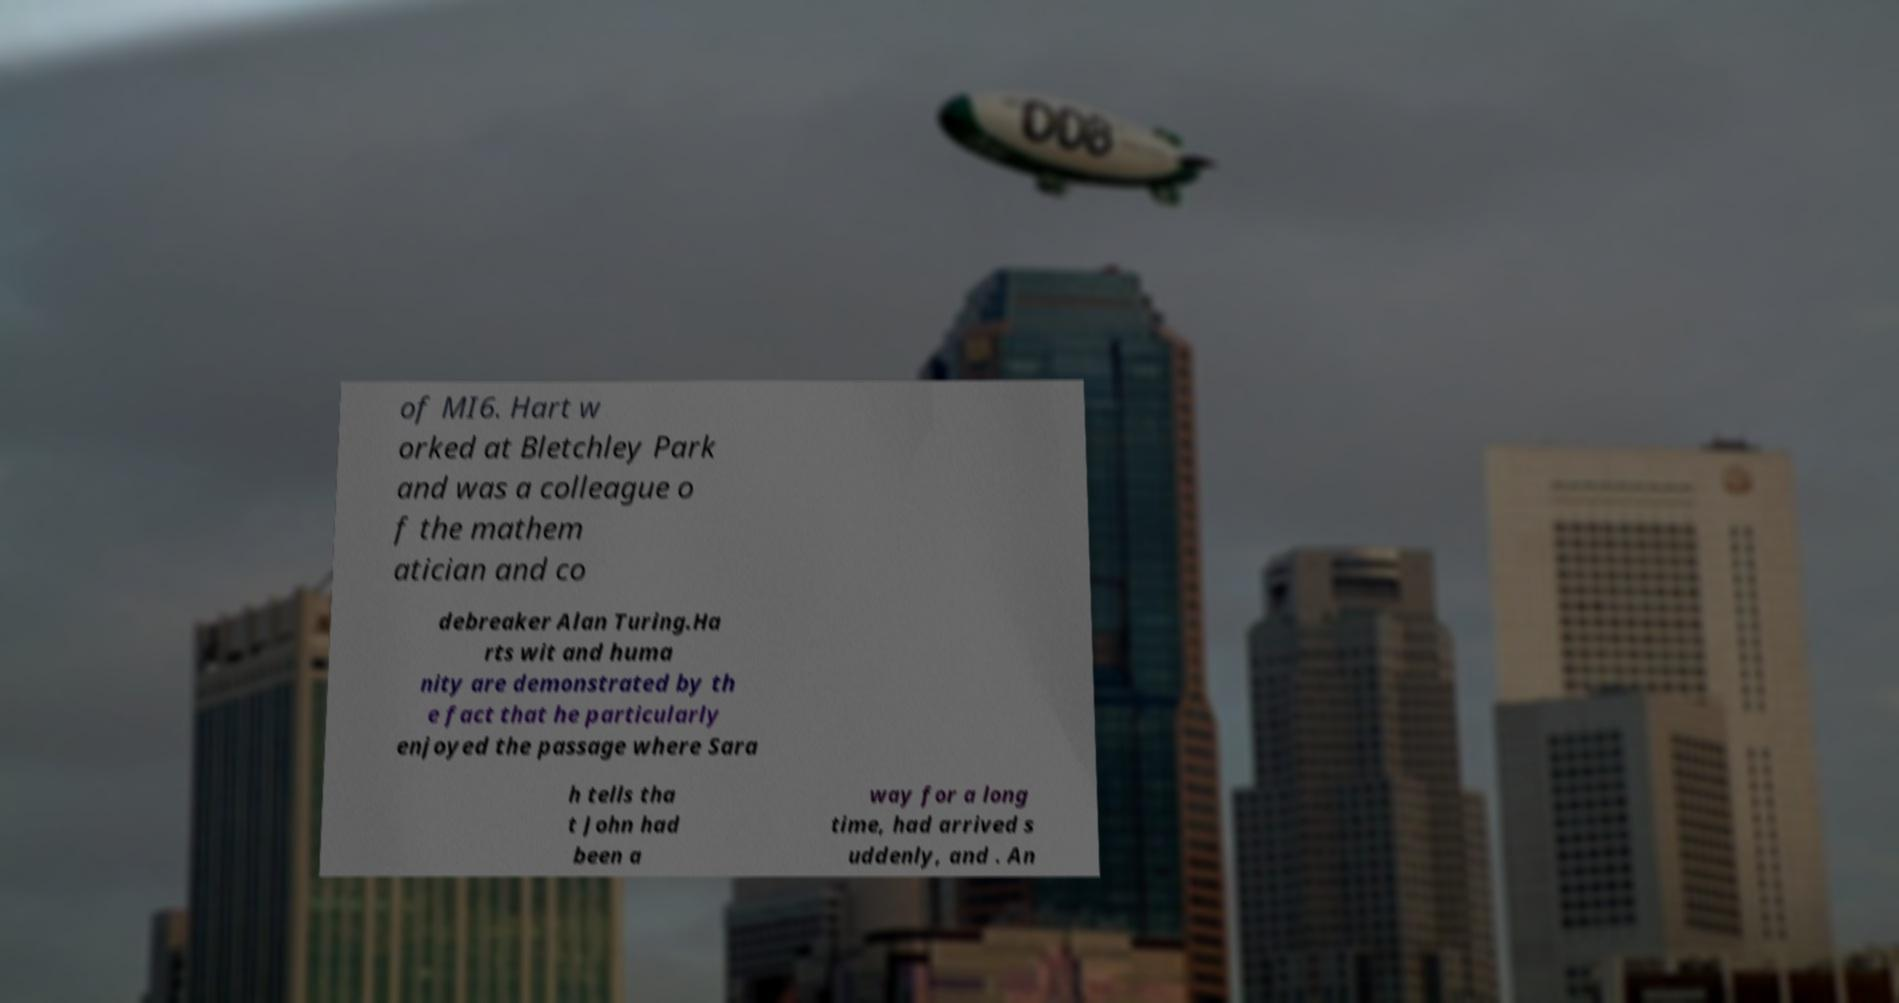Can you accurately transcribe the text from the provided image for me? of MI6. Hart w orked at Bletchley Park and was a colleague o f the mathem atician and co debreaker Alan Turing.Ha rts wit and huma nity are demonstrated by th e fact that he particularly enjoyed the passage where Sara h tells tha t John had been a way for a long time, had arrived s uddenly, and . An 